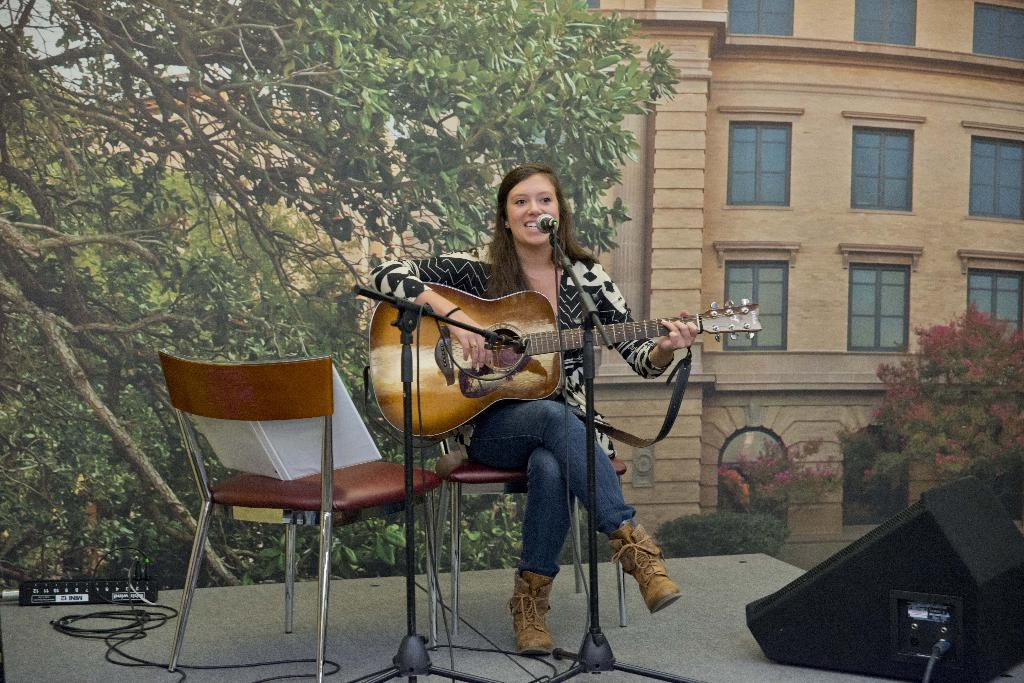What is the woman in the center of the image doing? The woman is sitting in the center of the image and holding a guitar. What object is in front of the woman? There is a microphone in front of the woman. What can be seen in the background of the image? There is a building, a window, trees, a recorder, a chair, a plant, and a speaker in the background of the image. Can you see a lamp in the image? There is no lamp present in the image. Are there any worms crawling on the guitar in the image? There are no worms visible in the image, and the guitar is not being crawled on by any creatures. 